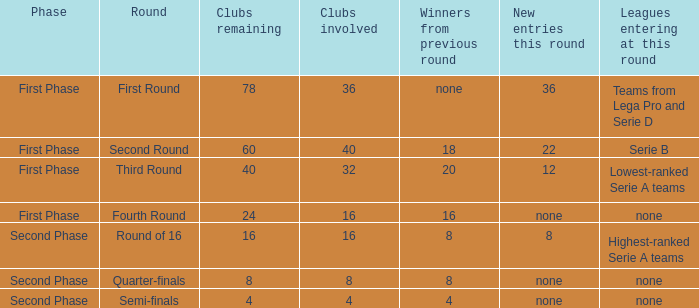During the first part of the phase with 16 clubs, who were the victorious teams from the last round? 16.0. 